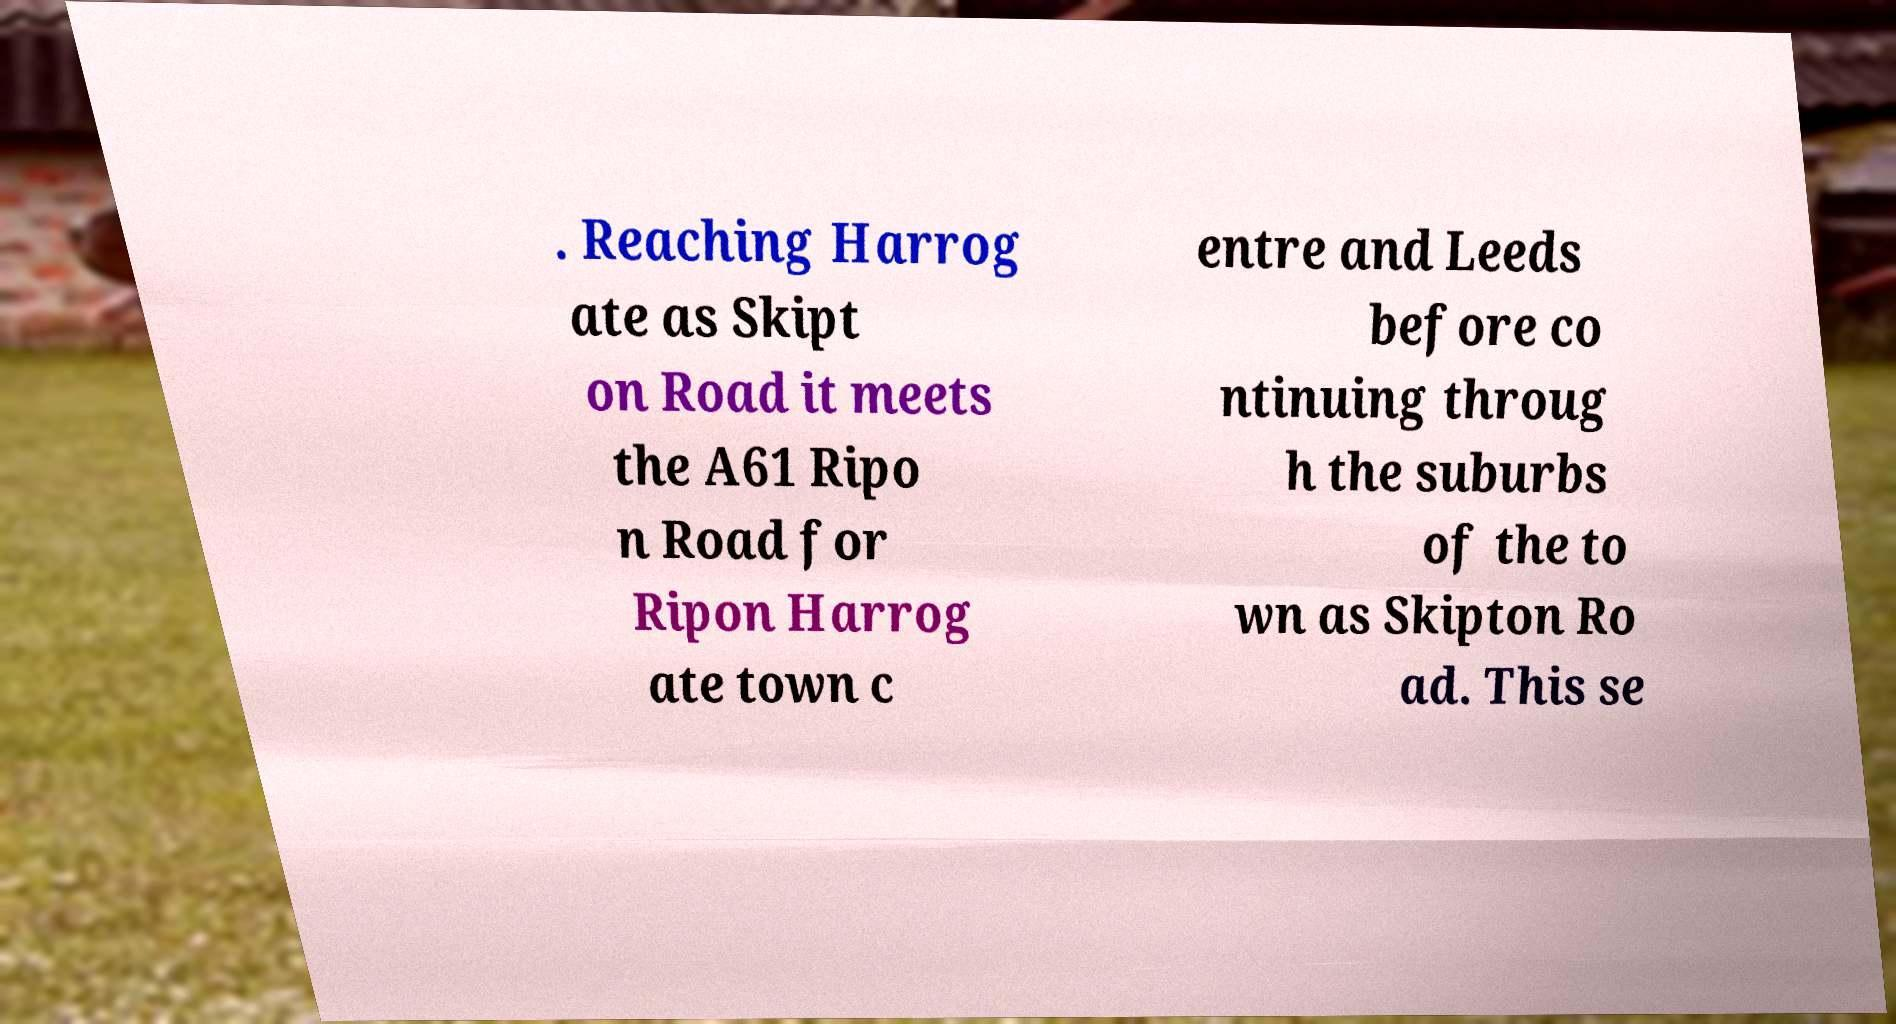Please identify and transcribe the text found in this image. . Reaching Harrog ate as Skipt on Road it meets the A61 Ripo n Road for Ripon Harrog ate town c entre and Leeds before co ntinuing throug h the suburbs of the to wn as Skipton Ro ad. This se 